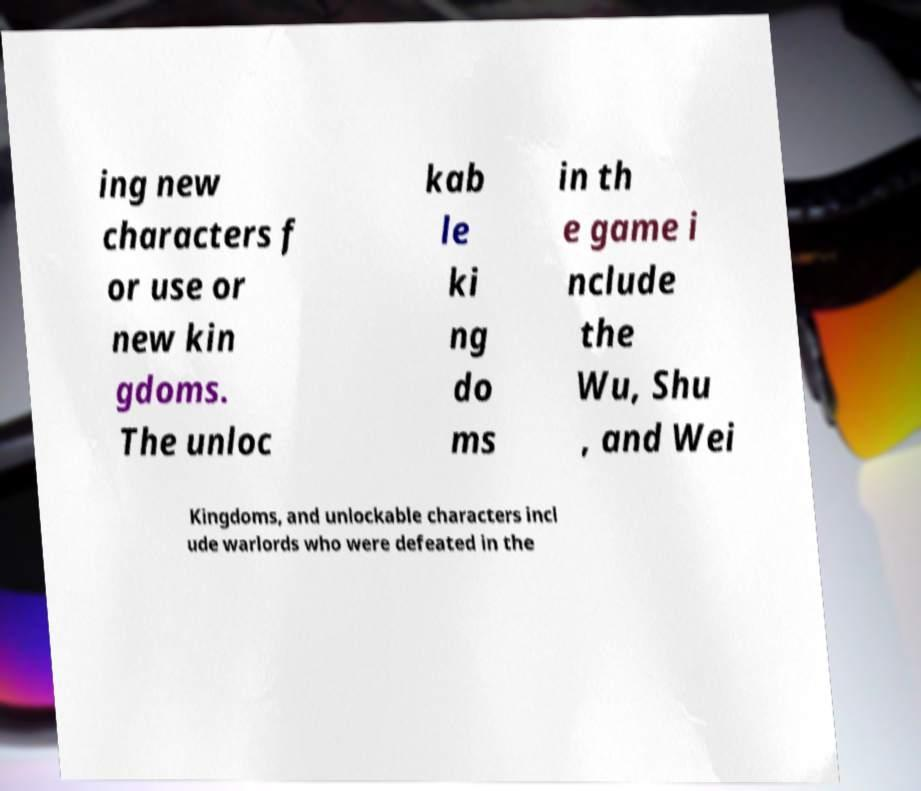Please read and relay the text visible in this image. What does it say? ing new characters f or use or new kin gdoms. The unloc kab le ki ng do ms in th e game i nclude the Wu, Shu , and Wei Kingdoms, and unlockable characters incl ude warlords who were defeated in the 